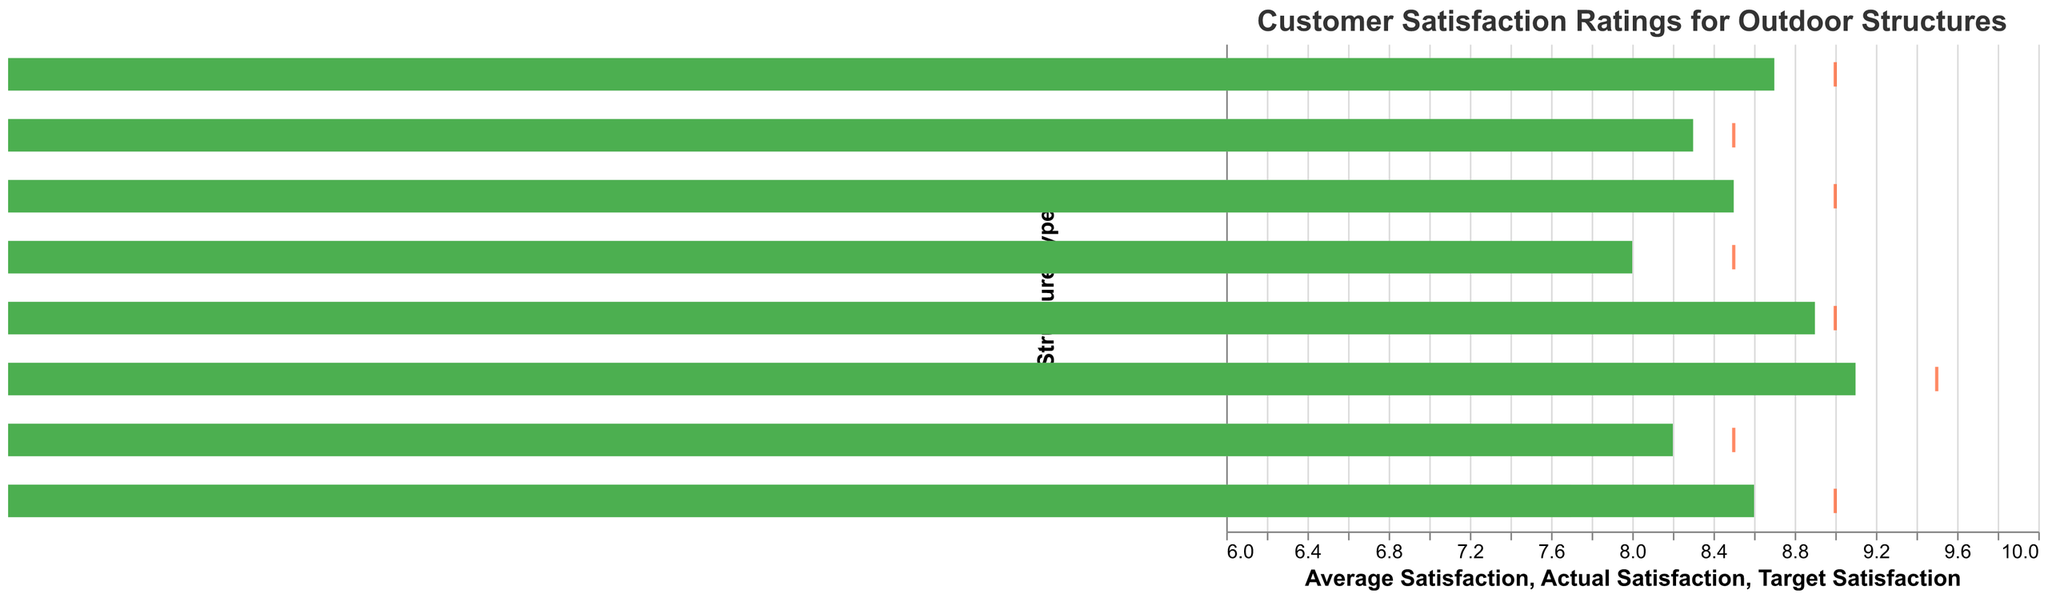What is the title of the chart? The title of the chart is typically displayed at the top and provides an overview of what the chart is about. In this case, the title is "Customer Satisfaction Ratings for Outdoor Structures".
Answer: Customer Satisfaction Ratings for Outdoor Structures How many different structure types are shown in the chart? Count the number of distinct structure types listed along the y-axis. There are 8 unique structure types in the data provided.
Answer: 8 Which structure type has the highest actual satisfaction rating? By examining the length of the green bars, we see that "Outdoor Kitchens" has the highest actual satisfaction rating at 9.1.
Answer: Outdoor Kitchens Which structure type is closest to meeting its target satisfaction rating? Look for the tick mark that's closest to the end of the green bar. "Gazebos" has an actual satisfaction of 8.9 and a target of 9.0, so it's the closest.
Answer: Gazebos What is the average satisfaction rating for Decks? The chart shows a grey bar representing the average satisfaction rating for each structure type. For Decks, the grey bar corresponds to 7.5.
Answer: 7.5 What is the difference between the actual satisfaction ratings of Fire Pits and Pergolas? Subtract the actual satisfaction rating of Pergolas (8.2) from Fire Pits (8.5). The difference is 8.5 - 8.2.
Answer: 0.3 Which structure type has the largest gap between its actual satisfaction and the target satisfaction rating? Calculate the difference between actual and target satisfaction for each type, then compare. "Outdoor Kitchens" has the largest gap: 9.5 - 9.1 = 0.4.
Answer: Outdoor Kitchens Are there any structure types where the actual satisfaction exceeds the average satisfaction by more than 1 point? Compare the actual satisfaction and average satisfaction for each type. "Outdoor Kitchens" (9.1 > 8.0) exceeds its average by more than 1 point.
Answer: Yes How do customer satisfaction ratings for Fences compare to those for Garden Arbors? Compare the green bars and tick marks. For Fences, actual satisfaction is 8.3, target is 8.5. For Garden Arbors, actual is 8.0, target is 8.5. Fences have higher actual and average satisfaction.
Answer: Fences have higher ratings What structure types meet their average satisfaction rating? The average satisfaction rating is represented by the grey bar. Structure types that meet their average satisfaction have their green bar extending beyond the grey. "Outdoor Kitchens" (Actual: 9.1, Average: 8.0) meets the average.
Answer: Outdoor Kitchens 